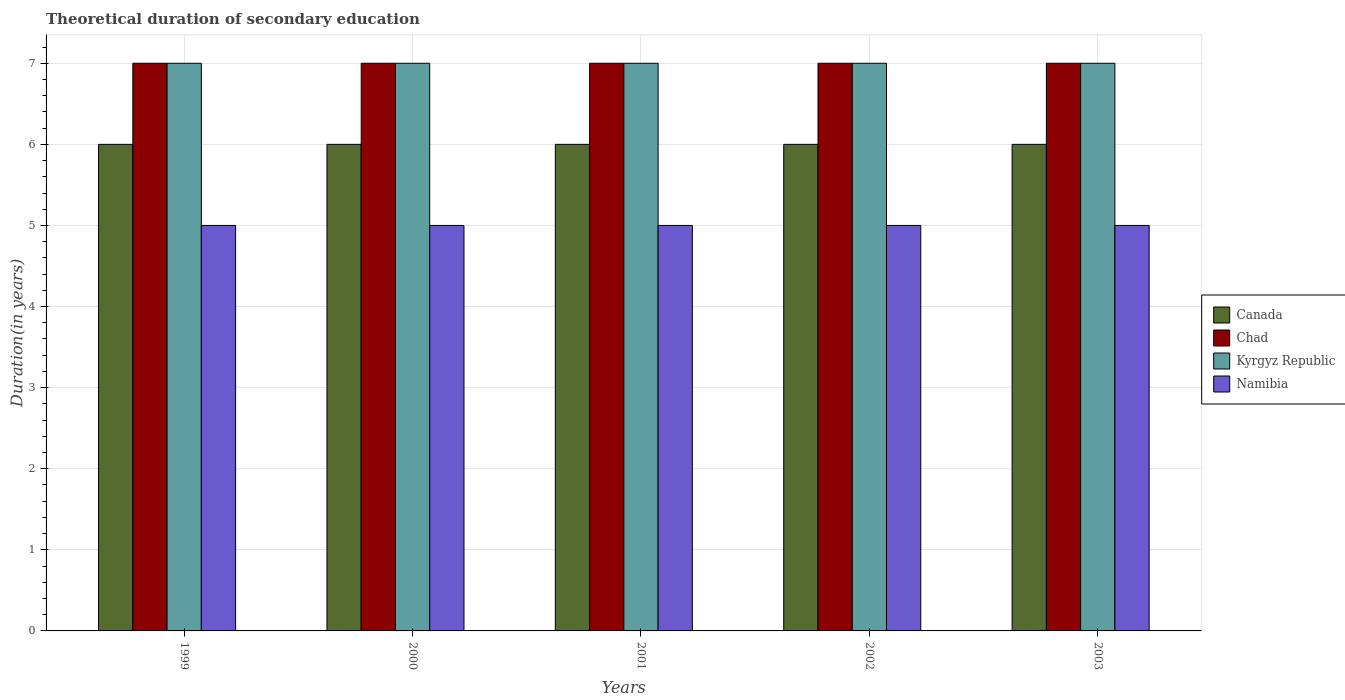How many different coloured bars are there?
Offer a terse response. 4. How many groups of bars are there?
Offer a terse response. 5. Are the number of bars on each tick of the X-axis equal?
Offer a terse response. Yes. How many bars are there on the 5th tick from the right?
Ensure brevity in your answer.  4. What is the label of the 1st group of bars from the left?
Ensure brevity in your answer.  1999. What is the total theoretical duration of secondary education in Chad in 2002?
Keep it short and to the point. 7. Across all years, what is the maximum total theoretical duration of secondary education in Kyrgyz Republic?
Provide a succinct answer. 7. Across all years, what is the minimum total theoretical duration of secondary education in Namibia?
Provide a short and direct response. 5. In which year was the total theoretical duration of secondary education in Chad minimum?
Your answer should be very brief. 1999. What is the total total theoretical duration of secondary education in Chad in the graph?
Offer a very short reply. 35. What is the difference between the total theoretical duration of secondary education in Chad in 1999 and that in 2001?
Provide a short and direct response. 0. What is the difference between the total theoretical duration of secondary education in Canada in 2000 and the total theoretical duration of secondary education in Chad in 2002?
Your response must be concise. -1. What is the average total theoretical duration of secondary education in Namibia per year?
Your answer should be very brief. 5. In the year 1999, what is the difference between the total theoretical duration of secondary education in Kyrgyz Republic and total theoretical duration of secondary education in Namibia?
Ensure brevity in your answer.  2. In how many years, is the total theoretical duration of secondary education in Chad greater than 4 years?
Your answer should be compact. 5. Is the total theoretical duration of secondary education in Canada in 1999 less than that in 2000?
Your answer should be very brief. No. Are all the bars in the graph horizontal?
Offer a terse response. No. What is the difference between two consecutive major ticks on the Y-axis?
Your answer should be very brief. 1. Does the graph contain any zero values?
Your answer should be compact. No. Where does the legend appear in the graph?
Give a very brief answer. Center right. How are the legend labels stacked?
Make the answer very short. Vertical. What is the title of the graph?
Your answer should be compact. Theoretical duration of secondary education. What is the label or title of the X-axis?
Offer a terse response. Years. What is the label or title of the Y-axis?
Your answer should be compact. Duration(in years). What is the Duration(in years) in Canada in 1999?
Provide a short and direct response. 6. What is the Duration(in years) in Chad in 1999?
Your answer should be very brief. 7. What is the Duration(in years) of Kyrgyz Republic in 1999?
Offer a very short reply. 7. What is the Duration(in years) in Kyrgyz Republic in 2000?
Offer a terse response. 7. What is the Duration(in years) in Namibia in 2000?
Your answer should be very brief. 5. What is the Duration(in years) in Canada in 2002?
Give a very brief answer. 6. What is the Duration(in years) in Chad in 2002?
Keep it short and to the point. 7. What is the Duration(in years) in Kyrgyz Republic in 2002?
Your answer should be very brief. 7. What is the Duration(in years) of Namibia in 2002?
Offer a very short reply. 5. What is the Duration(in years) in Canada in 2003?
Give a very brief answer. 6. What is the Duration(in years) in Namibia in 2003?
Make the answer very short. 5. Across all years, what is the maximum Duration(in years) of Chad?
Your response must be concise. 7. Across all years, what is the maximum Duration(in years) of Kyrgyz Republic?
Ensure brevity in your answer.  7. Across all years, what is the maximum Duration(in years) of Namibia?
Provide a short and direct response. 5. Across all years, what is the minimum Duration(in years) of Chad?
Offer a terse response. 7. Across all years, what is the minimum Duration(in years) of Kyrgyz Republic?
Your answer should be compact. 7. Across all years, what is the minimum Duration(in years) of Namibia?
Offer a terse response. 5. What is the total Duration(in years) of Canada in the graph?
Keep it short and to the point. 30. What is the total Duration(in years) of Chad in the graph?
Keep it short and to the point. 35. What is the total Duration(in years) of Namibia in the graph?
Your answer should be very brief. 25. What is the difference between the Duration(in years) in Canada in 1999 and that in 2000?
Your answer should be very brief. 0. What is the difference between the Duration(in years) in Chad in 1999 and that in 2000?
Provide a succinct answer. 0. What is the difference between the Duration(in years) in Kyrgyz Republic in 1999 and that in 2000?
Make the answer very short. 0. What is the difference between the Duration(in years) in Namibia in 1999 and that in 2001?
Offer a very short reply. 0. What is the difference between the Duration(in years) in Kyrgyz Republic in 1999 and that in 2002?
Provide a succinct answer. 0. What is the difference between the Duration(in years) of Namibia in 1999 and that in 2002?
Provide a short and direct response. 0. What is the difference between the Duration(in years) of Chad in 2000 and that in 2001?
Offer a very short reply. 0. What is the difference between the Duration(in years) of Kyrgyz Republic in 2000 and that in 2001?
Offer a terse response. 0. What is the difference between the Duration(in years) in Namibia in 2000 and that in 2001?
Keep it short and to the point. 0. What is the difference between the Duration(in years) of Namibia in 2000 and that in 2002?
Give a very brief answer. 0. What is the difference between the Duration(in years) in Canada in 2000 and that in 2003?
Offer a very short reply. 0. What is the difference between the Duration(in years) of Chad in 2000 and that in 2003?
Ensure brevity in your answer.  0. What is the difference between the Duration(in years) of Canada in 2001 and that in 2002?
Your response must be concise. 0. What is the difference between the Duration(in years) of Kyrgyz Republic in 2001 and that in 2002?
Your answer should be compact. 0. What is the difference between the Duration(in years) in Canada in 2001 and that in 2003?
Make the answer very short. 0. What is the difference between the Duration(in years) in Chad in 2001 and that in 2003?
Give a very brief answer. 0. What is the difference between the Duration(in years) of Canada in 2002 and that in 2003?
Make the answer very short. 0. What is the difference between the Duration(in years) in Chad in 2002 and that in 2003?
Offer a terse response. 0. What is the difference between the Duration(in years) in Kyrgyz Republic in 2002 and that in 2003?
Provide a short and direct response. 0. What is the difference between the Duration(in years) in Namibia in 2002 and that in 2003?
Keep it short and to the point. 0. What is the difference between the Duration(in years) in Chad in 1999 and the Duration(in years) in Namibia in 2000?
Keep it short and to the point. 2. What is the difference between the Duration(in years) in Kyrgyz Republic in 1999 and the Duration(in years) in Namibia in 2000?
Your answer should be compact. 2. What is the difference between the Duration(in years) of Canada in 1999 and the Duration(in years) of Chad in 2001?
Your answer should be very brief. -1. What is the difference between the Duration(in years) of Canada in 1999 and the Duration(in years) of Kyrgyz Republic in 2001?
Give a very brief answer. -1. What is the difference between the Duration(in years) of Canada in 1999 and the Duration(in years) of Kyrgyz Republic in 2002?
Keep it short and to the point. -1. What is the difference between the Duration(in years) of Canada in 1999 and the Duration(in years) of Kyrgyz Republic in 2003?
Offer a very short reply. -1. What is the difference between the Duration(in years) in Canada in 1999 and the Duration(in years) in Namibia in 2003?
Give a very brief answer. 1. What is the difference between the Duration(in years) in Chad in 1999 and the Duration(in years) in Kyrgyz Republic in 2003?
Offer a very short reply. 0. What is the difference between the Duration(in years) of Chad in 1999 and the Duration(in years) of Namibia in 2003?
Ensure brevity in your answer.  2. What is the difference between the Duration(in years) in Kyrgyz Republic in 1999 and the Duration(in years) in Namibia in 2003?
Your answer should be compact. 2. What is the difference between the Duration(in years) in Canada in 2000 and the Duration(in years) in Chad in 2001?
Make the answer very short. -1. What is the difference between the Duration(in years) of Canada in 2000 and the Duration(in years) of Kyrgyz Republic in 2001?
Offer a very short reply. -1. What is the difference between the Duration(in years) in Canada in 2000 and the Duration(in years) in Namibia in 2001?
Give a very brief answer. 1. What is the difference between the Duration(in years) in Kyrgyz Republic in 2000 and the Duration(in years) in Namibia in 2001?
Provide a succinct answer. 2. What is the difference between the Duration(in years) in Canada in 2000 and the Duration(in years) in Chad in 2002?
Ensure brevity in your answer.  -1. What is the difference between the Duration(in years) of Canada in 2000 and the Duration(in years) of Kyrgyz Republic in 2002?
Make the answer very short. -1. What is the difference between the Duration(in years) of Canada in 2000 and the Duration(in years) of Namibia in 2002?
Keep it short and to the point. 1. What is the difference between the Duration(in years) in Canada in 2000 and the Duration(in years) in Kyrgyz Republic in 2003?
Provide a short and direct response. -1. What is the difference between the Duration(in years) of Chad in 2000 and the Duration(in years) of Namibia in 2003?
Give a very brief answer. 2. What is the difference between the Duration(in years) of Canada in 2001 and the Duration(in years) of Kyrgyz Republic in 2002?
Make the answer very short. -1. What is the difference between the Duration(in years) in Chad in 2001 and the Duration(in years) in Namibia in 2002?
Your answer should be very brief. 2. What is the difference between the Duration(in years) in Kyrgyz Republic in 2001 and the Duration(in years) in Namibia in 2002?
Make the answer very short. 2. What is the difference between the Duration(in years) of Canada in 2001 and the Duration(in years) of Kyrgyz Republic in 2003?
Offer a terse response. -1. What is the difference between the Duration(in years) of Canada in 2001 and the Duration(in years) of Namibia in 2003?
Provide a succinct answer. 1. What is the difference between the Duration(in years) of Chad in 2001 and the Duration(in years) of Kyrgyz Republic in 2003?
Ensure brevity in your answer.  0. What is the difference between the Duration(in years) in Chad in 2001 and the Duration(in years) in Namibia in 2003?
Provide a succinct answer. 2. What is the difference between the Duration(in years) in Canada in 2002 and the Duration(in years) in Chad in 2003?
Your answer should be compact. -1. What is the difference between the Duration(in years) in Canada in 2002 and the Duration(in years) in Kyrgyz Republic in 2003?
Your answer should be very brief. -1. What is the difference between the Duration(in years) in Canada in 2002 and the Duration(in years) in Namibia in 2003?
Your answer should be compact. 1. What is the difference between the Duration(in years) in Chad in 2002 and the Duration(in years) in Kyrgyz Republic in 2003?
Make the answer very short. 0. What is the difference between the Duration(in years) of Chad in 2002 and the Duration(in years) of Namibia in 2003?
Ensure brevity in your answer.  2. What is the difference between the Duration(in years) of Kyrgyz Republic in 2002 and the Duration(in years) of Namibia in 2003?
Make the answer very short. 2. What is the average Duration(in years) of Canada per year?
Make the answer very short. 6. What is the average Duration(in years) in Chad per year?
Offer a terse response. 7. What is the average Duration(in years) in Kyrgyz Republic per year?
Provide a succinct answer. 7. In the year 1999, what is the difference between the Duration(in years) of Canada and Duration(in years) of Kyrgyz Republic?
Ensure brevity in your answer.  -1. In the year 1999, what is the difference between the Duration(in years) of Chad and Duration(in years) of Kyrgyz Republic?
Offer a very short reply. 0. In the year 1999, what is the difference between the Duration(in years) of Chad and Duration(in years) of Namibia?
Your response must be concise. 2. In the year 1999, what is the difference between the Duration(in years) of Kyrgyz Republic and Duration(in years) of Namibia?
Provide a short and direct response. 2. In the year 2000, what is the difference between the Duration(in years) of Kyrgyz Republic and Duration(in years) of Namibia?
Keep it short and to the point. 2. In the year 2001, what is the difference between the Duration(in years) of Canada and Duration(in years) of Chad?
Make the answer very short. -1. In the year 2001, what is the difference between the Duration(in years) in Canada and Duration(in years) in Kyrgyz Republic?
Provide a short and direct response. -1. In the year 2001, what is the difference between the Duration(in years) of Chad and Duration(in years) of Namibia?
Ensure brevity in your answer.  2. In the year 2002, what is the difference between the Duration(in years) of Canada and Duration(in years) of Chad?
Provide a short and direct response. -1. In the year 2002, what is the difference between the Duration(in years) of Canada and Duration(in years) of Kyrgyz Republic?
Give a very brief answer. -1. In the year 2002, what is the difference between the Duration(in years) in Canada and Duration(in years) in Namibia?
Offer a very short reply. 1. In the year 2002, what is the difference between the Duration(in years) of Chad and Duration(in years) of Kyrgyz Republic?
Your answer should be compact. 0. In the year 2002, what is the difference between the Duration(in years) of Chad and Duration(in years) of Namibia?
Your response must be concise. 2. In the year 2002, what is the difference between the Duration(in years) in Kyrgyz Republic and Duration(in years) in Namibia?
Give a very brief answer. 2. In the year 2003, what is the difference between the Duration(in years) in Chad and Duration(in years) in Namibia?
Your answer should be very brief. 2. In the year 2003, what is the difference between the Duration(in years) of Kyrgyz Republic and Duration(in years) of Namibia?
Ensure brevity in your answer.  2. What is the ratio of the Duration(in years) of Canada in 1999 to that in 2001?
Keep it short and to the point. 1. What is the ratio of the Duration(in years) of Chad in 1999 to that in 2001?
Offer a very short reply. 1. What is the ratio of the Duration(in years) in Kyrgyz Republic in 1999 to that in 2001?
Your answer should be very brief. 1. What is the ratio of the Duration(in years) in Namibia in 1999 to that in 2001?
Your answer should be compact. 1. What is the ratio of the Duration(in years) in Canada in 1999 to that in 2002?
Make the answer very short. 1. What is the ratio of the Duration(in years) in Kyrgyz Republic in 1999 to that in 2002?
Give a very brief answer. 1. What is the ratio of the Duration(in years) in Namibia in 1999 to that in 2002?
Ensure brevity in your answer.  1. What is the ratio of the Duration(in years) of Namibia in 1999 to that in 2003?
Make the answer very short. 1. What is the ratio of the Duration(in years) in Chad in 2000 to that in 2001?
Ensure brevity in your answer.  1. What is the ratio of the Duration(in years) of Kyrgyz Republic in 2000 to that in 2001?
Provide a succinct answer. 1. What is the ratio of the Duration(in years) in Chad in 2000 to that in 2002?
Your answer should be very brief. 1. What is the ratio of the Duration(in years) of Kyrgyz Republic in 2000 to that in 2002?
Your answer should be very brief. 1. What is the ratio of the Duration(in years) in Chad in 2000 to that in 2003?
Your answer should be very brief. 1. What is the ratio of the Duration(in years) of Kyrgyz Republic in 2000 to that in 2003?
Your answer should be very brief. 1. What is the ratio of the Duration(in years) in Namibia in 2000 to that in 2003?
Keep it short and to the point. 1. What is the ratio of the Duration(in years) in Chad in 2001 to that in 2002?
Make the answer very short. 1. What is the ratio of the Duration(in years) in Namibia in 2001 to that in 2002?
Keep it short and to the point. 1. What is the ratio of the Duration(in years) of Kyrgyz Republic in 2001 to that in 2003?
Your response must be concise. 1. What is the ratio of the Duration(in years) in Kyrgyz Republic in 2002 to that in 2003?
Provide a short and direct response. 1. What is the ratio of the Duration(in years) of Namibia in 2002 to that in 2003?
Your answer should be very brief. 1. What is the difference between the highest and the second highest Duration(in years) in Chad?
Offer a terse response. 0. What is the difference between the highest and the second highest Duration(in years) of Kyrgyz Republic?
Keep it short and to the point. 0. What is the difference between the highest and the second highest Duration(in years) of Namibia?
Offer a very short reply. 0. What is the difference between the highest and the lowest Duration(in years) of Canada?
Ensure brevity in your answer.  0. What is the difference between the highest and the lowest Duration(in years) in Chad?
Offer a very short reply. 0. 